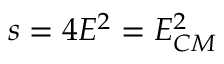Convert formula to latex. <formula><loc_0><loc_0><loc_500><loc_500>s = 4 E ^ { 2 } = E _ { C M } ^ { 2 }</formula> 